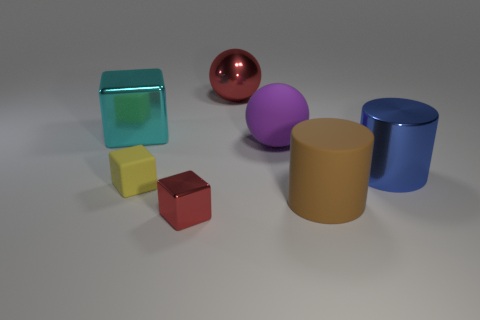Are there fewer small yellow matte blocks that are on the right side of the big purple ball than large green balls?
Keep it short and to the point. No. Is the big cyan metallic object the same shape as the big blue object?
Your response must be concise. No. How big is the red metallic object that is in front of the big blue metal thing?
Your response must be concise. Small. There is a red block that is made of the same material as the cyan thing; what is its size?
Offer a terse response. Small. Is the number of small yellow rubber cubes less than the number of shiny things?
Keep it short and to the point. Yes. What is the material of the other cube that is the same size as the yellow cube?
Make the answer very short. Metal. Is the number of tiny purple cylinders greater than the number of big brown cylinders?
Keep it short and to the point. No. What number of other objects are the same color as the small shiny block?
Your answer should be very brief. 1. How many things are behind the brown cylinder and left of the brown cylinder?
Give a very brief answer. 4. Is there anything else that has the same size as the yellow thing?
Make the answer very short. Yes. 